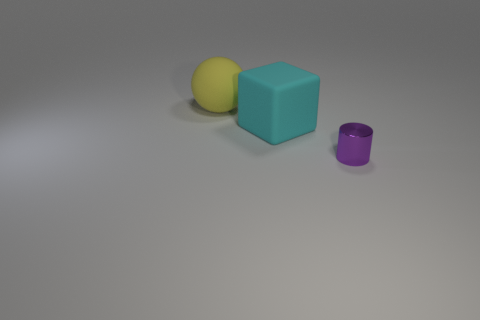Add 1 red metal things. How many objects exist? 4 Subtract all cylinders. How many objects are left? 2 Subtract 0 cyan spheres. How many objects are left? 3 Subtract all brown rubber cylinders. Subtract all small purple objects. How many objects are left? 2 Add 3 big matte blocks. How many big matte blocks are left? 4 Add 3 tiny metallic cylinders. How many tiny metallic cylinders exist? 4 